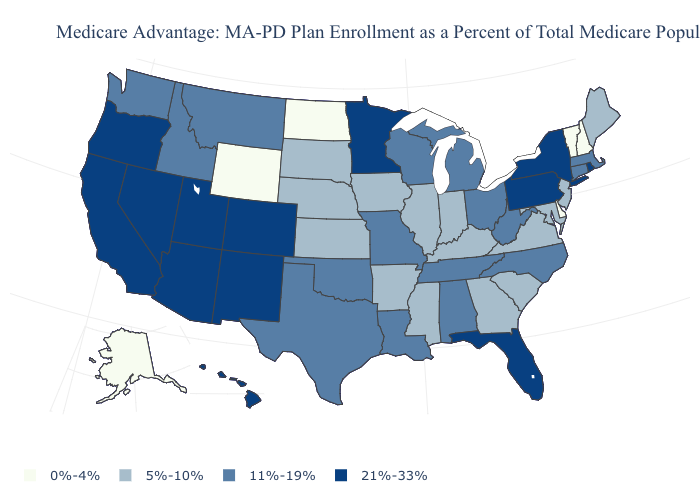Does Alaska have the lowest value in the USA?
Keep it brief. Yes. What is the highest value in states that border Oregon?
Answer briefly. 21%-33%. Which states have the lowest value in the West?
Answer briefly. Alaska, Wyoming. What is the highest value in the USA?
Write a very short answer. 21%-33%. What is the value of Georgia?
Give a very brief answer. 5%-10%. What is the highest value in the West ?
Give a very brief answer. 21%-33%. What is the value of Wisconsin?
Write a very short answer. 11%-19%. Which states have the lowest value in the USA?
Keep it brief. Alaska, Delaware, North Dakota, New Hampshire, Vermont, Wyoming. Does Louisiana have a lower value than Washington?
Short answer required. No. Name the states that have a value in the range 0%-4%?
Keep it brief. Alaska, Delaware, North Dakota, New Hampshire, Vermont, Wyoming. What is the value of Colorado?
Short answer required. 21%-33%. What is the value of Alabama?
Keep it brief. 11%-19%. What is the lowest value in the South?
Short answer required. 0%-4%. What is the lowest value in the MidWest?
Write a very short answer. 0%-4%. Name the states that have a value in the range 0%-4%?
Be succinct. Alaska, Delaware, North Dakota, New Hampshire, Vermont, Wyoming. 